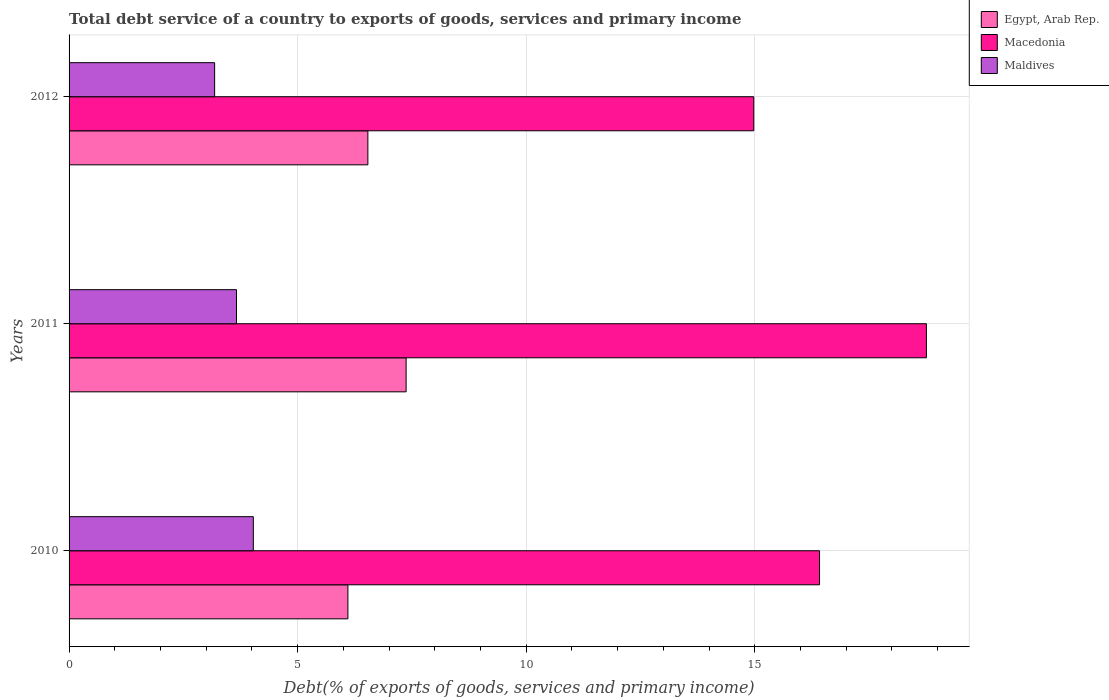How many different coloured bars are there?
Keep it short and to the point. 3. How many groups of bars are there?
Offer a very short reply. 3. How many bars are there on the 3rd tick from the top?
Make the answer very short. 3. How many bars are there on the 1st tick from the bottom?
Your answer should be very brief. 3. What is the label of the 1st group of bars from the top?
Your answer should be compact. 2012. What is the total debt service in Egypt, Arab Rep. in 2011?
Offer a terse response. 7.37. Across all years, what is the maximum total debt service in Macedonia?
Your answer should be very brief. 18.75. Across all years, what is the minimum total debt service in Egypt, Arab Rep.?
Your answer should be compact. 6.1. In which year was the total debt service in Macedonia maximum?
Make the answer very short. 2011. In which year was the total debt service in Egypt, Arab Rep. minimum?
Offer a very short reply. 2010. What is the total total debt service in Egypt, Arab Rep. in the graph?
Your answer should be very brief. 20.01. What is the difference between the total debt service in Macedonia in 2010 and that in 2011?
Keep it short and to the point. -2.34. What is the difference between the total debt service in Macedonia in 2010 and the total debt service in Egypt, Arab Rep. in 2011?
Your response must be concise. 9.04. What is the average total debt service in Egypt, Arab Rep. per year?
Your answer should be very brief. 6.67. In the year 2010, what is the difference between the total debt service in Maldives and total debt service in Macedonia?
Offer a very short reply. -12.39. In how many years, is the total debt service in Maldives greater than 4 %?
Provide a succinct answer. 1. What is the ratio of the total debt service in Egypt, Arab Rep. in 2011 to that in 2012?
Give a very brief answer. 1.13. Is the difference between the total debt service in Maldives in 2011 and 2012 greater than the difference between the total debt service in Macedonia in 2011 and 2012?
Keep it short and to the point. No. What is the difference between the highest and the second highest total debt service in Macedonia?
Your answer should be very brief. 2.34. What is the difference between the highest and the lowest total debt service in Maldives?
Provide a short and direct response. 0.85. What does the 3rd bar from the top in 2012 represents?
Provide a succinct answer. Egypt, Arab Rep. What does the 2nd bar from the bottom in 2010 represents?
Make the answer very short. Macedonia. Is it the case that in every year, the sum of the total debt service in Maldives and total debt service in Egypt, Arab Rep. is greater than the total debt service in Macedonia?
Your answer should be compact. No. How many bars are there?
Provide a short and direct response. 9. Are all the bars in the graph horizontal?
Offer a terse response. Yes. What is the difference between two consecutive major ticks on the X-axis?
Offer a very short reply. 5. Are the values on the major ticks of X-axis written in scientific E-notation?
Provide a short and direct response. No. Does the graph contain any zero values?
Offer a very short reply. No. Where does the legend appear in the graph?
Make the answer very short. Top right. How many legend labels are there?
Offer a terse response. 3. How are the legend labels stacked?
Keep it short and to the point. Vertical. What is the title of the graph?
Provide a succinct answer. Total debt service of a country to exports of goods, services and primary income. What is the label or title of the X-axis?
Your answer should be very brief. Debt(% of exports of goods, services and primary income). What is the label or title of the Y-axis?
Provide a succinct answer. Years. What is the Debt(% of exports of goods, services and primary income) in Egypt, Arab Rep. in 2010?
Make the answer very short. 6.1. What is the Debt(% of exports of goods, services and primary income) in Macedonia in 2010?
Ensure brevity in your answer.  16.42. What is the Debt(% of exports of goods, services and primary income) in Maldives in 2010?
Provide a succinct answer. 4.03. What is the Debt(% of exports of goods, services and primary income) of Egypt, Arab Rep. in 2011?
Your answer should be very brief. 7.37. What is the Debt(% of exports of goods, services and primary income) of Macedonia in 2011?
Offer a terse response. 18.75. What is the Debt(% of exports of goods, services and primary income) in Maldives in 2011?
Your response must be concise. 3.66. What is the Debt(% of exports of goods, services and primary income) of Egypt, Arab Rep. in 2012?
Your answer should be compact. 6.54. What is the Debt(% of exports of goods, services and primary income) of Macedonia in 2012?
Provide a succinct answer. 14.98. What is the Debt(% of exports of goods, services and primary income) in Maldives in 2012?
Make the answer very short. 3.18. Across all years, what is the maximum Debt(% of exports of goods, services and primary income) in Egypt, Arab Rep.?
Provide a short and direct response. 7.37. Across all years, what is the maximum Debt(% of exports of goods, services and primary income) in Macedonia?
Your answer should be compact. 18.75. Across all years, what is the maximum Debt(% of exports of goods, services and primary income) of Maldives?
Ensure brevity in your answer.  4.03. Across all years, what is the minimum Debt(% of exports of goods, services and primary income) of Egypt, Arab Rep.?
Give a very brief answer. 6.1. Across all years, what is the minimum Debt(% of exports of goods, services and primary income) in Macedonia?
Make the answer very short. 14.98. Across all years, what is the minimum Debt(% of exports of goods, services and primary income) of Maldives?
Offer a very short reply. 3.18. What is the total Debt(% of exports of goods, services and primary income) of Egypt, Arab Rep. in the graph?
Offer a terse response. 20.01. What is the total Debt(% of exports of goods, services and primary income) in Macedonia in the graph?
Offer a very short reply. 50.15. What is the total Debt(% of exports of goods, services and primary income) in Maldives in the graph?
Your answer should be very brief. 10.88. What is the difference between the Debt(% of exports of goods, services and primary income) in Egypt, Arab Rep. in 2010 and that in 2011?
Your answer should be compact. -1.27. What is the difference between the Debt(% of exports of goods, services and primary income) of Macedonia in 2010 and that in 2011?
Offer a very short reply. -2.34. What is the difference between the Debt(% of exports of goods, services and primary income) of Maldives in 2010 and that in 2011?
Provide a short and direct response. 0.37. What is the difference between the Debt(% of exports of goods, services and primary income) in Egypt, Arab Rep. in 2010 and that in 2012?
Offer a terse response. -0.44. What is the difference between the Debt(% of exports of goods, services and primary income) of Macedonia in 2010 and that in 2012?
Your answer should be compact. 1.44. What is the difference between the Debt(% of exports of goods, services and primary income) in Maldives in 2010 and that in 2012?
Keep it short and to the point. 0.85. What is the difference between the Debt(% of exports of goods, services and primary income) of Egypt, Arab Rep. in 2011 and that in 2012?
Your answer should be compact. 0.84. What is the difference between the Debt(% of exports of goods, services and primary income) in Macedonia in 2011 and that in 2012?
Provide a succinct answer. 3.78. What is the difference between the Debt(% of exports of goods, services and primary income) of Maldives in 2011 and that in 2012?
Give a very brief answer. 0.48. What is the difference between the Debt(% of exports of goods, services and primary income) of Egypt, Arab Rep. in 2010 and the Debt(% of exports of goods, services and primary income) of Macedonia in 2011?
Provide a succinct answer. -12.65. What is the difference between the Debt(% of exports of goods, services and primary income) in Egypt, Arab Rep. in 2010 and the Debt(% of exports of goods, services and primary income) in Maldives in 2011?
Provide a short and direct response. 2.44. What is the difference between the Debt(% of exports of goods, services and primary income) in Macedonia in 2010 and the Debt(% of exports of goods, services and primary income) in Maldives in 2011?
Make the answer very short. 12.75. What is the difference between the Debt(% of exports of goods, services and primary income) in Egypt, Arab Rep. in 2010 and the Debt(% of exports of goods, services and primary income) in Macedonia in 2012?
Give a very brief answer. -8.88. What is the difference between the Debt(% of exports of goods, services and primary income) of Egypt, Arab Rep. in 2010 and the Debt(% of exports of goods, services and primary income) of Maldives in 2012?
Keep it short and to the point. 2.92. What is the difference between the Debt(% of exports of goods, services and primary income) of Macedonia in 2010 and the Debt(% of exports of goods, services and primary income) of Maldives in 2012?
Offer a very short reply. 13.23. What is the difference between the Debt(% of exports of goods, services and primary income) of Egypt, Arab Rep. in 2011 and the Debt(% of exports of goods, services and primary income) of Macedonia in 2012?
Make the answer very short. -7.61. What is the difference between the Debt(% of exports of goods, services and primary income) in Egypt, Arab Rep. in 2011 and the Debt(% of exports of goods, services and primary income) in Maldives in 2012?
Give a very brief answer. 4.19. What is the difference between the Debt(% of exports of goods, services and primary income) in Macedonia in 2011 and the Debt(% of exports of goods, services and primary income) in Maldives in 2012?
Provide a short and direct response. 15.57. What is the average Debt(% of exports of goods, services and primary income) of Egypt, Arab Rep. per year?
Your answer should be very brief. 6.67. What is the average Debt(% of exports of goods, services and primary income) in Macedonia per year?
Provide a succinct answer. 16.72. What is the average Debt(% of exports of goods, services and primary income) of Maldives per year?
Ensure brevity in your answer.  3.63. In the year 2010, what is the difference between the Debt(% of exports of goods, services and primary income) in Egypt, Arab Rep. and Debt(% of exports of goods, services and primary income) in Macedonia?
Provide a short and direct response. -10.32. In the year 2010, what is the difference between the Debt(% of exports of goods, services and primary income) of Egypt, Arab Rep. and Debt(% of exports of goods, services and primary income) of Maldives?
Give a very brief answer. 2.07. In the year 2010, what is the difference between the Debt(% of exports of goods, services and primary income) in Macedonia and Debt(% of exports of goods, services and primary income) in Maldives?
Keep it short and to the point. 12.39. In the year 2011, what is the difference between the Debt(% of exports of goods, services and primary income) in Egypt, Arab Rep. and Debt(% of exports of goods, services and primary income) in Macedonia?
Ensure brevity in your answer.  -11.38. In the year 2011, what is the difference between the Debt(% of exports of goods, services and primary income) in Egypt, Arab Rep. and Debt(% of exports of goods, services and primary income) in Maldives?
Give a very brief answer. 3.71. In the year 2011, what is the difference between the Debt(% of exports of goods, services and primary income) of Macedonia and Debt(% of exports of goods, services and primary income) of Maldives?
Offer a very short reply. 15.09. In the year 2012, what is the difference between the Debt(% of exports of goods, services and primary income) of Egypt, Arab Rep. and Debt(% of exports of goods, services and primary income) of Macedonia?
Ensure brevity in your answer.  -8.44. In the year 2012, what is the difference between the Debt(% of exports of goods, services and primary income) in Egypt, Arab Rep. and Debt(% of exports of goods, services and primary income) in Maldives?
Make the answer very short. 3.35. In the year 2012, what is the difference between the Debt(% of exports of goods, services and primary income) of Macedonia and Debt(% of exports of goods, services and primary income) of Maldives?
Your answer should be very brief. 11.79. What is the ratio of the Debt(% of exports of goods, services and primary income) of Egypt, Arab Rep. in 2010 to that in 2011?
Your response must be concise. 0.83. What is the ratio of the Debt(% of exports of goods, services and primary income) in Macedonia in 2010 to that in 2011?
Your answer should be compact. 0.88. What is the ratio of the Debt(% of exports of goods, services and primary income) in Maldives in 2010 to that in 2011?
Your answer should be compact. 1.1. What is the ratio of the Debt(% of exports of goods, services and primary income) in Egypt, Arab Rep. in 2010 to that in 2012?
Ensure brevity in your answer.  0.93. What is the ratio of the Debt(% of exports of goods, services and primary income) of Macedonia in 2010 to that in 2012?
Your answer should be compact. 1.1. What is the ratio of the Debt(% of exports of goods, services and primary income) of Maldives in 2010 to that in 2012?
Provide a succinct answer. 1.27. What is the ratio of the Debt(% of exports of goods, services and primary income) in Egypt, Arab Rep. in 2011 to that in 2012?
Keep it short and to the point. 1.13. What is the ratio of the Debt(% of exports of goods, services and primary income) of Macedonia in 2011 to that in 2012?
Your answer should be very brief. 1.25. What is the ratio of the Debt(% of exports of goods, services and primary income) of Maldives in 2011 to that in 2012?
Provide a succinct answer. 1.15. What is the difference between the highest and the second highest Debt(% of exports of goods, services and primary income) in Egypt, Arab Rep.?
Make the answer very short. 0.84. What is the difference between the highest and the second highest Debt(% of exports of goods, services and primary income) in Macedonia?
Make the answer very short. 2.34. What is the difference between the highest and the second highest Debt(% of exports of goods, services and primary income) in Maldives?
Provide a short and direct response. 0.37. What is the difference between the highest and the lowest Debt(% of exports of goods, services and primary income) of Egypt, Arab Rep.?
Offer a very short reply. 1.27. What is the difference between the highest and the lowest Debt(% of exports of goods, services and primary income) of Macedonia?
Ensure brevity in your answer.  3.78. What is the difference between the highest and the lowest Debt(% of exports of goods, services and primary income) of Maldives?
Give a very brief answer. 0.85. 